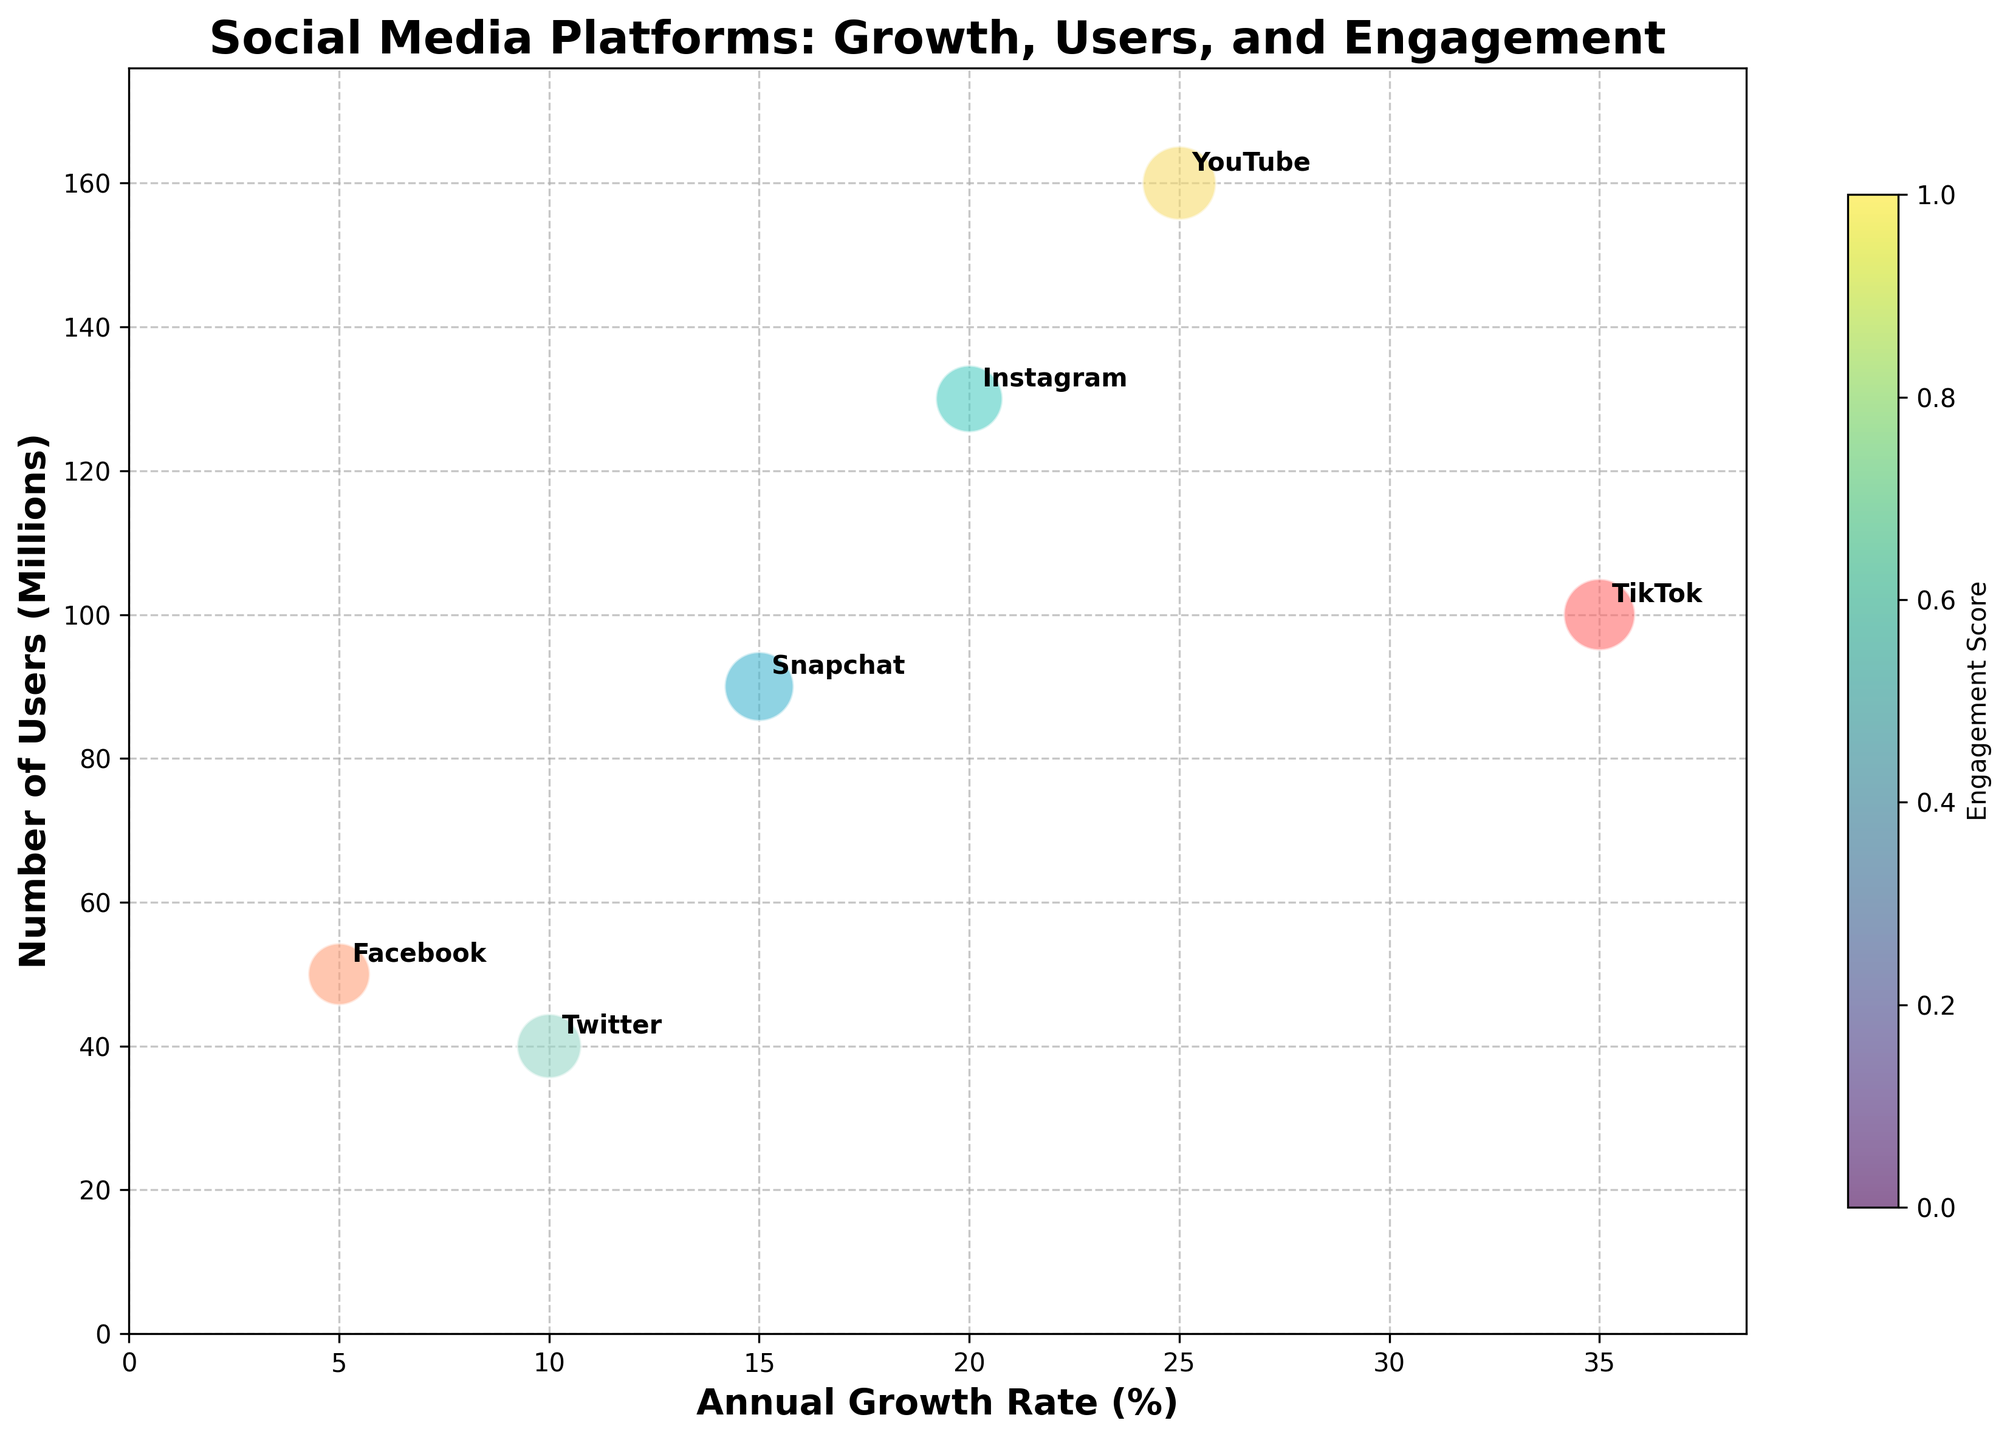What's the title of the figure? The title of the figure is typically found at the top of the chart. In this case, it reads "Social Media Platforms: Growth, Users, and Engagement".
Answer: Social Media Platforms: Growth, Users, and Engagement How many social media platforms are represented in the figure? Each bubble in the chart represents a social media platform. Counting the bubbles, there are six.
Answer: 6 Which social media platform has the highest annual growth rate? The x-axis represents the annual growth rate. The bubble farthest to the right represents TikTok, which has the highest annual growth rate.
Answer: TikTok Between Instagram and Snapchat, which has more users? The y-axis represents the number of users. The bubble representing Instagram is higher on the y-axis than the one representing Snapchat, so Instagram has more users.
Answer: Instagram Compare the engagement scores for TikTok and YouTube. Which one is higher? The engagement score is represented through the size of the bubbles, with larger bubbles having a higher score. TikTok's bubble is slightly smaller than YouTube's bubble, indicating a lower engagement score.
Answer: YouTube Which platform has the lowest number of users? The y-axis represents the number of users. The bubble nearest to the bottom of the chart represents Facebook, which has the lowest number of users.
Answer: Facebook What is the combined total number of users for Facebook and Twitter? Add the number of users for Facebook and Twitter by looking at their positions on the y-axis: 50 million (Facebook) + 40 million (Twitter) = 90 million.
Answer: 90 million Which platform is closest to having an equal number of users and engagement score? Find a bubble where the y-coordinate (number of users) is closest to the size of the bubble (engagement score). Snapchat has approximately 90 million users and an engagement score of 75, the closest among the platforms.
Answer: Snapchat Among TikTok, Instagram, and YouTube, which one has the lowest engagement score? Compare the sizes of the bubbles for TikTok, Instagram, and YouTube. Instagram's bubble appears the smallest among the three, indicating the lowest engagement score.
Answer: Instagram Which platform has the highest users-to-engagement score ratio? Divide the number of users (y-axis) by the engagement score (bubble size) for each platform and compare. YouTube has 160 million users and an engagement score of 85, resulting in a ratio of approximately 1.88, the highest among the platforms.
Answer: YouTube 